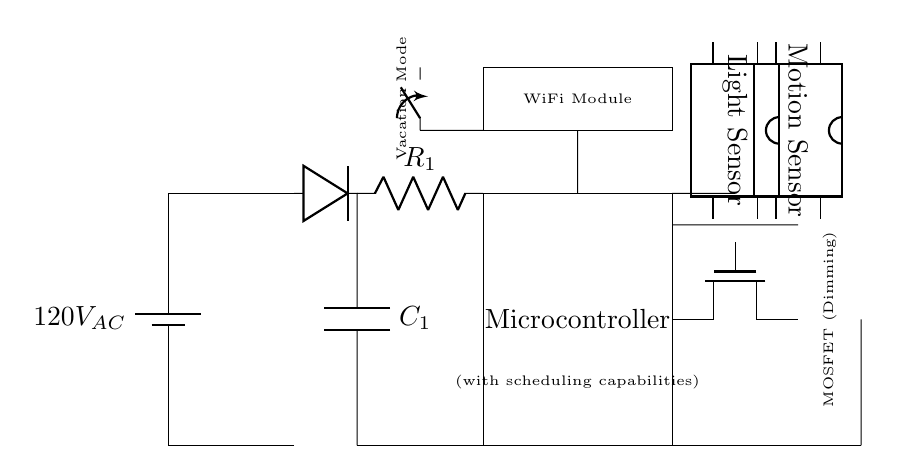What is the voltage of this circuit? The main voltage source is 120V AC, indicated by the battery symbol at the top of the circuit diagram.
Answer: 120V AC What component is responsible for dimming the light? The circuit includes a MOSFET labeled as "MOSFET (Dimming)" connected between the microcontroller and the LED light. This component regulates the brightness by controlling the current supplied to the light.
Answer: MOSFET What is the purpose of the light sensor in this circuit? The light sensor measures ambient light levels and sends this data to the microcontroller, which can adjust the LED's brightness based on the light conditions in the environment.
Answer: Ambient light measurement How does the circuit enable vacation simulation? The circuit includes a vacation mode switch, which alters the operation of the lights when engaged. This functionality, alongside scheduling from the microcontroller, simulates presence by controlling lighting as if someone is home.
Answer: Vacation mode switch Which component is used for communication with smart devices? There is a WiFi module labeled in the diagram that facilitates communication with smartphones or home networks, allowing for remote control and monitoring of the lighting system.
Answer: WiFi module What does the capacitor labeled C1 do in this circuit? The capacitor C1 smooths the output voltage from the rectifier, reducing fluctuations and providing a stable direct current to the microcontroller and control circuit, essential for proper operation.
Answer: Smoothing the voltage 